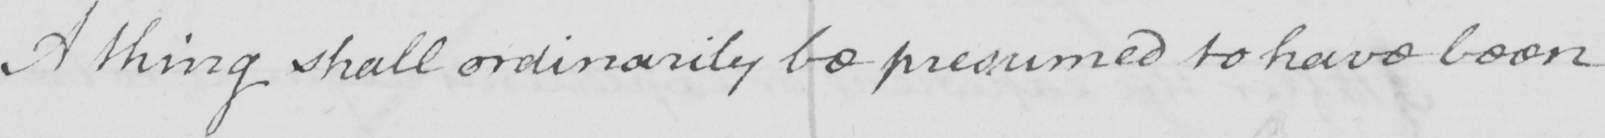What is written in this line of handwriting? A thing shall ordinarily be presumed to have been 